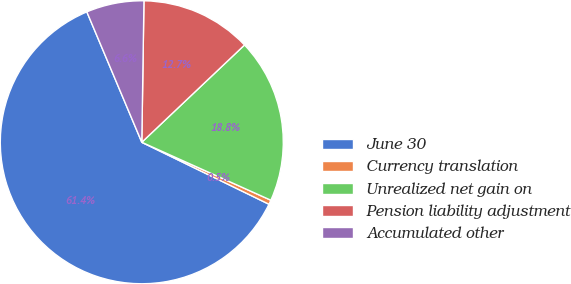Convert chart. <chart><loc_0><loc_0><loc_500><loc_500><pie_chart><fcel>June 30<fcel>Currency translation<fcel>Unrealized net gain on<fcel>Pension liability adjustment<fcel>Accumulated other<nl><fcel>61.43%<fcel>0.5%<fcel>18.78%<fcel>12.69%<fcel>6.59%<nl></chart> 